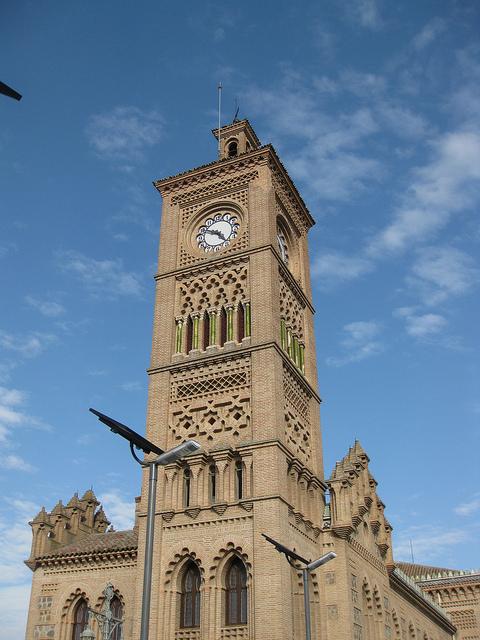What time does the clock on the tower say?
Give a very brief answer. 4:50. Is this a color photo?
Keep it brief. Yes. How many windows?
Concise answer only. 11. How many towers are there?
Short answer required. 1. What time is it?
Concise answer only. 4:50. What color is clock tower?
Short answer required. Brown. What time is shown?
Keep it brief. 9:20. What time is the clock displaying?
Concise answer only. 5:45. What time is on the clock?
Quick response, please. 4:45. Is this a movie theater?
Answer briefly. No. Is there a flag on the building?
Concise answer only. No. How many clocks are visible?
Be succinct. 2. What is near the camera?
Be succinct. Clock tower. What do you do in this building?
Give a very brief answer. Pray. Is this a church?
Be succinct. Yes. Is the time 5:02 PM?
Be succinct. No. What colors can be seen in this photo?
Quick response, please. Brown. Is this a business office?
Concise answer only. No. 